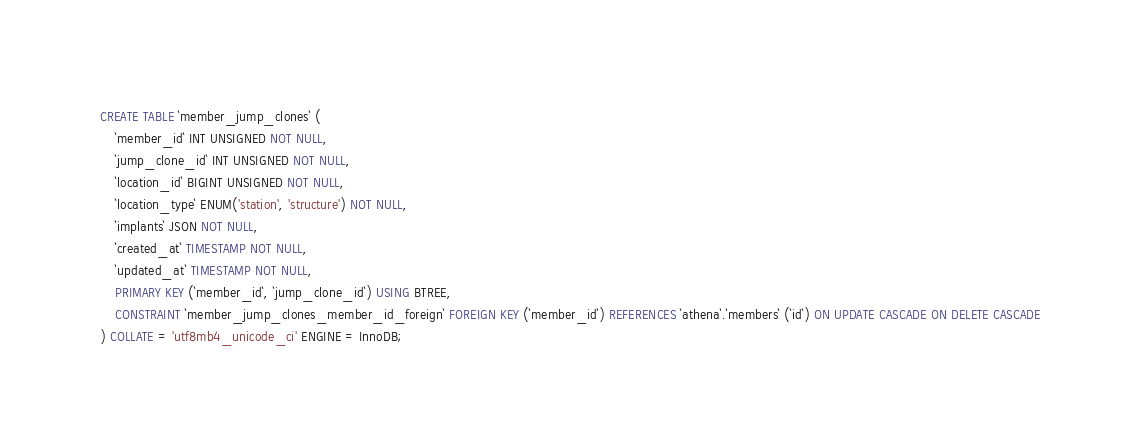<code> <loc_0><loc_0><loc_500><loc_500><_SQL_>CREATE TABLE `member_jump_clones` (
    `member_id` INT UNSIGNED NOT NULL,
    `jump_clone_id` INT UNSIGNED NOT NULL,
    `location_id` BIGINT UNSIGNED NOT NULL,
    `location_type` ENUM('station', 'structure') NOT NULL,
    `implants` JSON NOT NULL,
    `created_at` TIMESTAMP NOT NULL,
    `updated_at` TIMESTAMP NOT NULL,
    PRIMARY KEY (`member_id`, `jump_clone_id`) USING BTREE,
    CONSTRAINT `member_jump_clones_member_id_foreign` FOREIGN KEY (`member_id`) REFERENCES `athena`.`members` (`id`) ON UPDATE CASCADE ON DELETE CASCADE
) COLLATE = 'utf8mb4_unicode_ci' ENGINE = InnoDB;</code> 